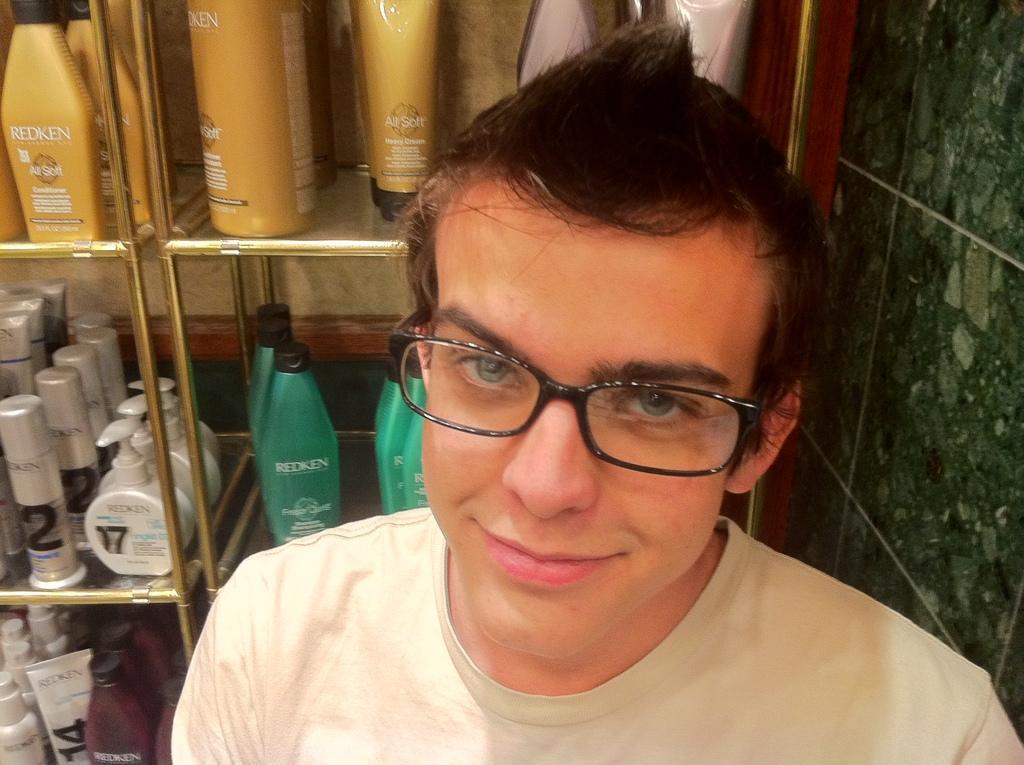Please provide a concise description of this image. In this image we can see a person. On the backside we can see some bottles and tubes which are placed in the racks. 